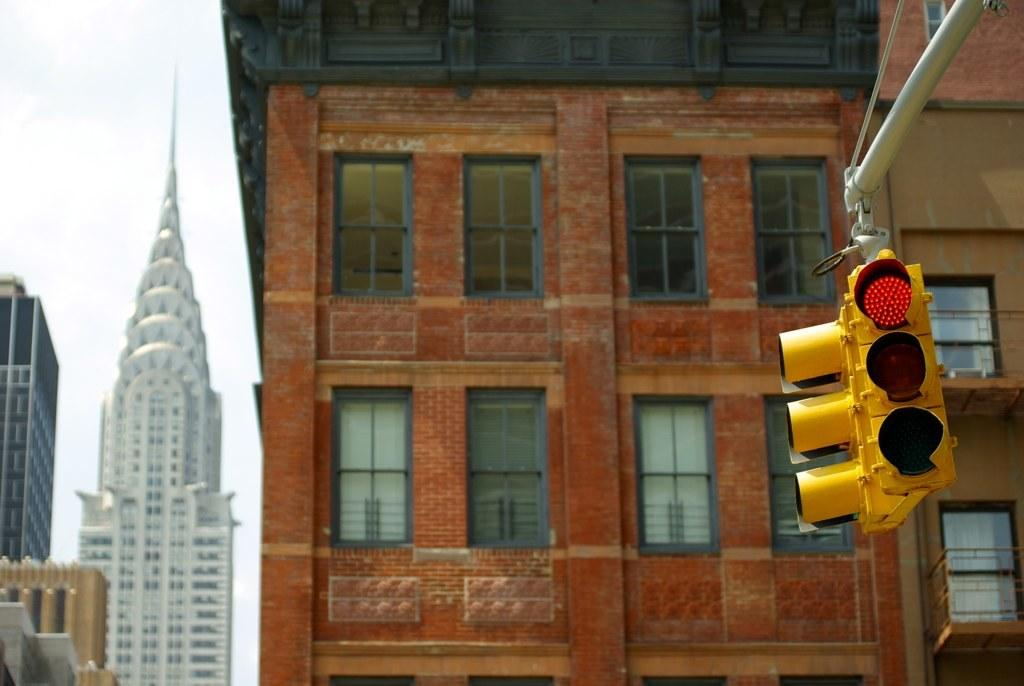What is the main subject in the foreground of the image? There is a traffic light pole in the foreground of the image. What type of structures can be seen in the image? Buildings are visible in the image. What feature is present on the buildings? Windows are present in the image. What part of the natural environment is visible in the image? The sky is visible in the image. Based on the visibility of the sky and the presence of sunlight, when do you think the image was taken? The image was likely taken during the day. How does the comb help the root of the tree in the image? There is no comb or tree present in the image; it features a traffic light pole and buildings. 